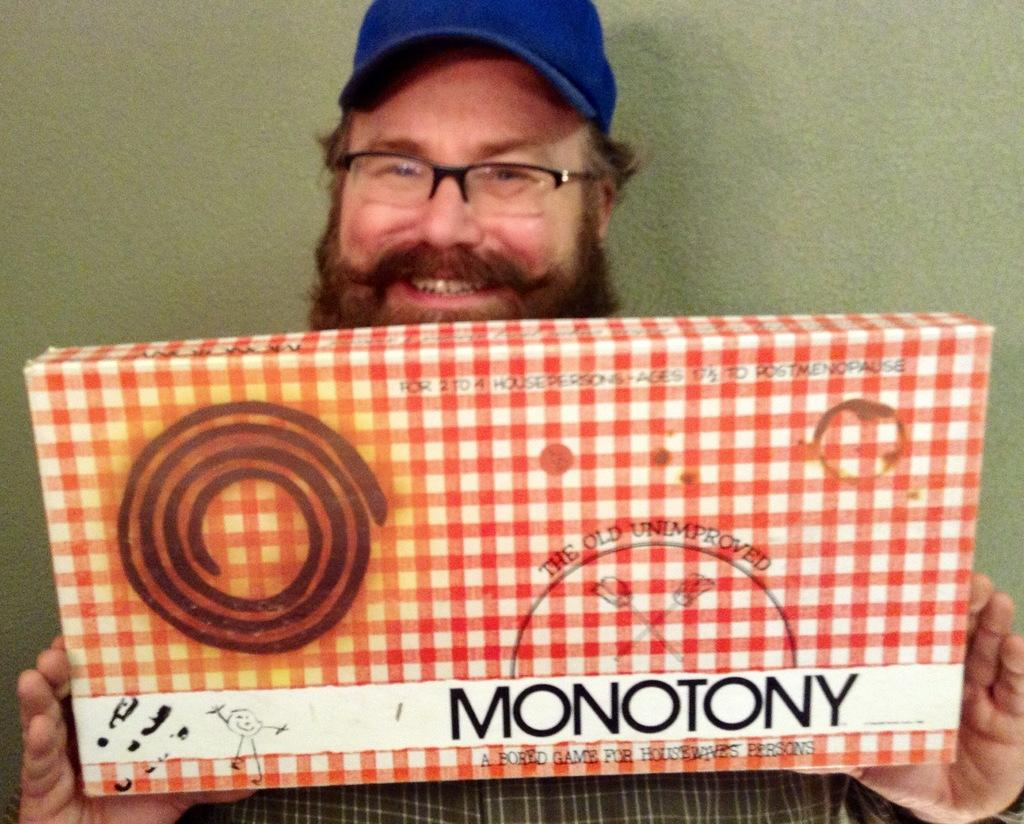Who is the main subject in the image? There is a man in the center of the image. What is the man holding in his hands? The man is holding a monotony box in his hands. What color is the scarf wrapped around the man's neck in the image? There is no scarf visible in the image; the man is only holding a monotony box. 